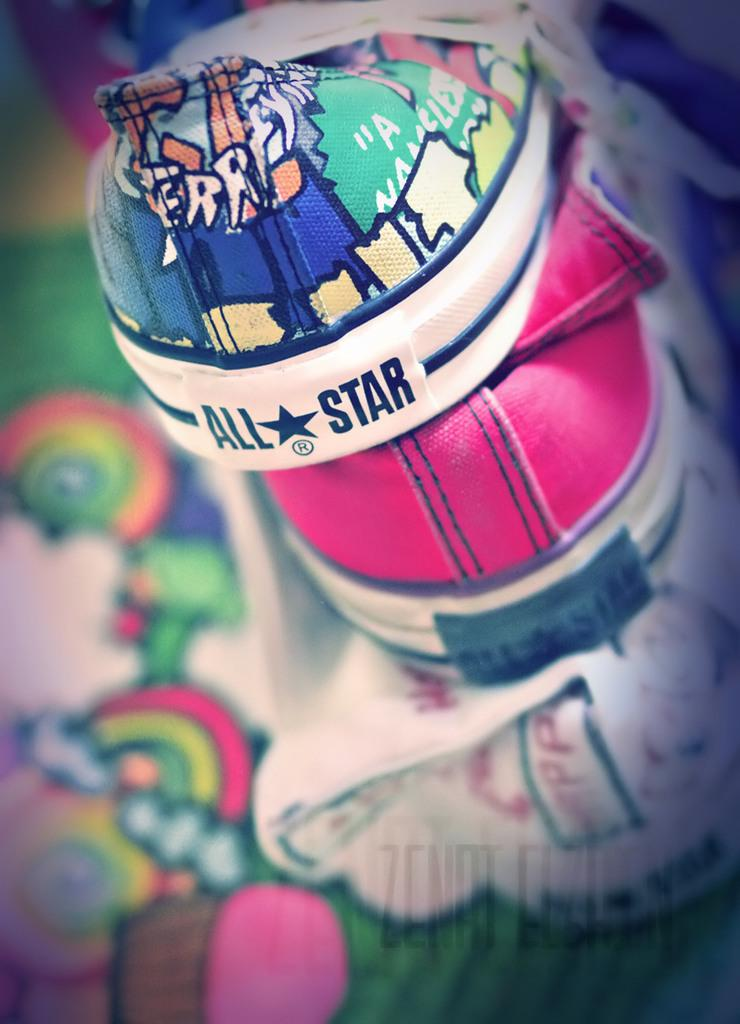What objects are present in the image? There are shoes in the image. Can you describe the area around the shoes? The area around the shoes is blurred. What types of toys can be seen in the image? There are no toys present in the image; it only features shoes and a blurred area. Where can you purchase these shoes in the image? The image does not show a shop or any indication of where the shoes can be purchased. 